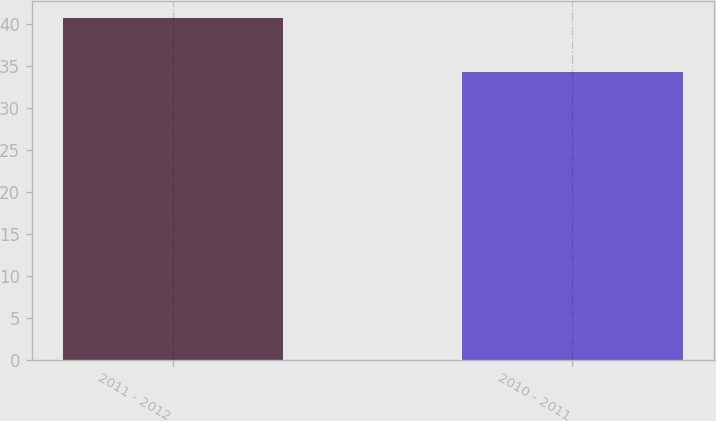Convert chart to OTSL. <chart><loc_0><loc_0><loc_500><loc_500><bar_chart><fcel>2011 - 2012<fcel>2010 - 2011<nl><fcel>40.7<fcel>34.3<nl></chart> 